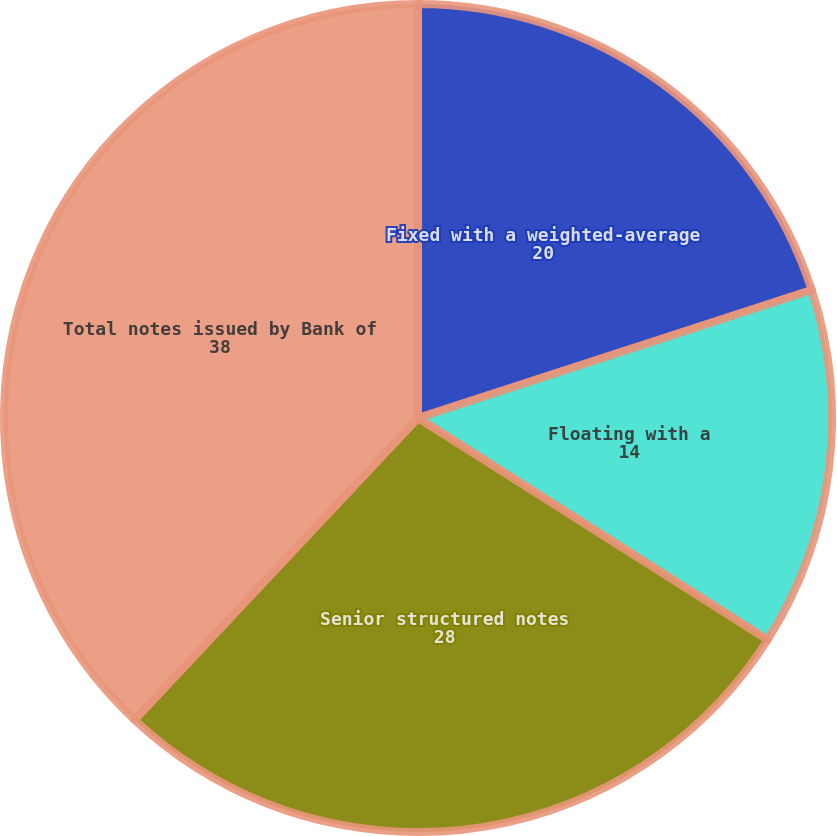Convert chart. <chart><loc_0><loc_0><loc_500><loc_500><pie_chart><fcel>Fixed with a weighted-average<fcel>Floating with a<fcel>Senior structured notes<fcel>Total notes issued by Bank of<nl><fcel>20.0%<fcel>14.0%<fcel>28.0%<fcel>38.0%<nl></chart> 